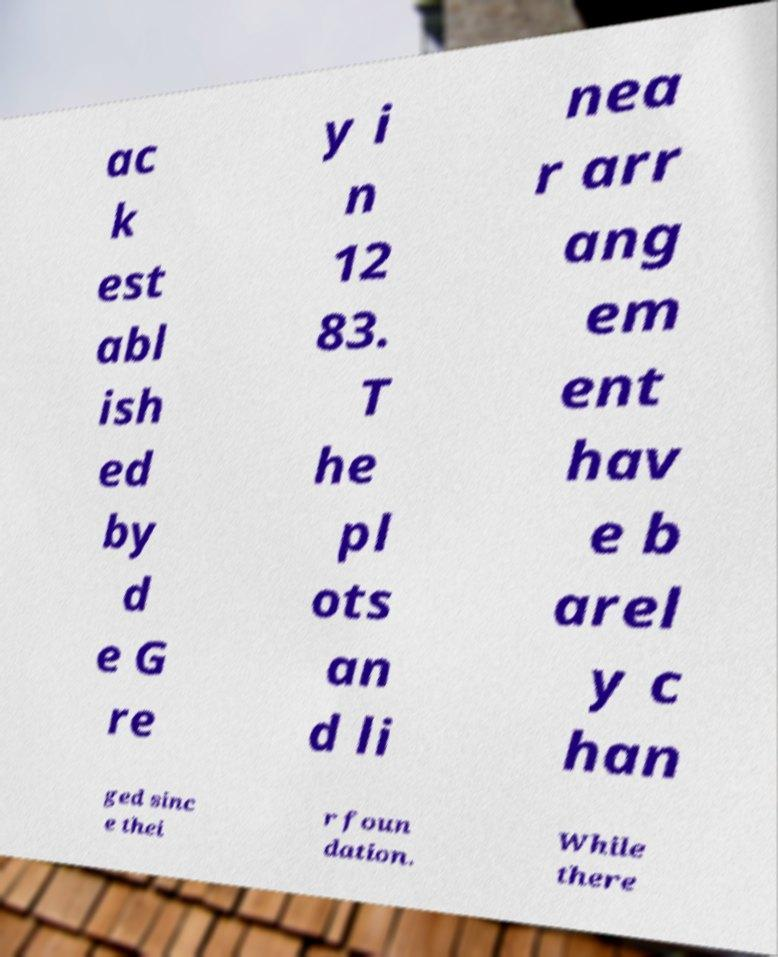Could you assist in decoding the text presented in this image and type it out clearly? ac k est abl ish ed by d e G re y i n 12 83. T he pl ots an d li nea r arr ang em ent hav e b arel y c han ged sinc e thei r foun dation. While there 